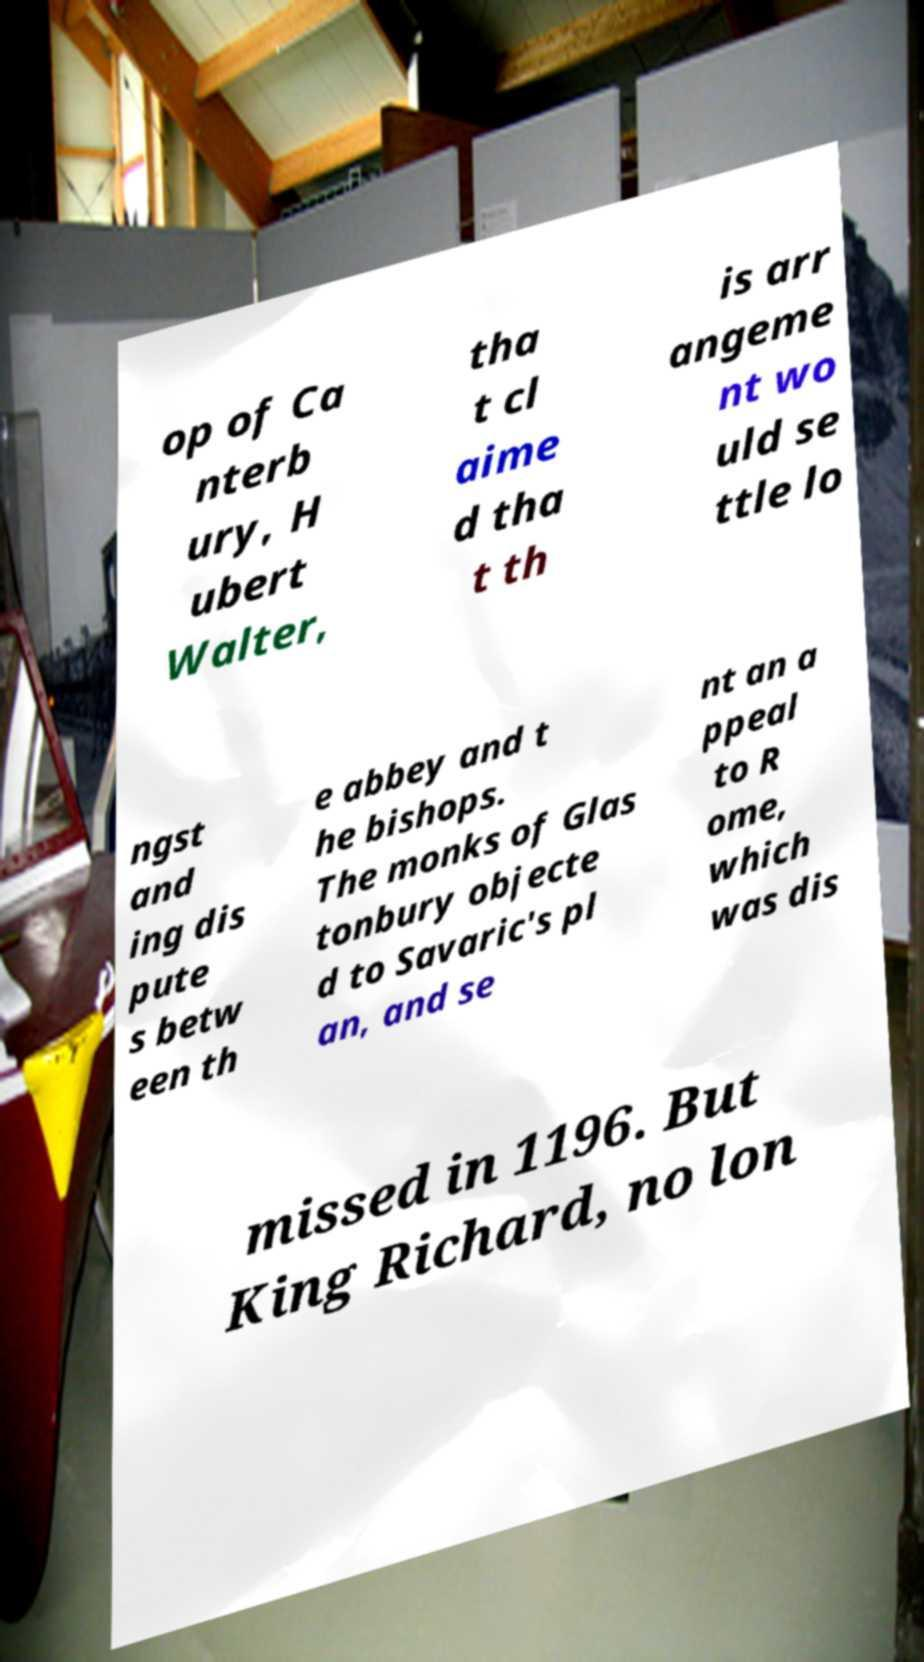Can you accurately transcribe the text from the provided image for me? op of Ca nterb ury, H ubert Walter, tha t cl aime d tha t th is arr angeme nt wo uld se ttle lo ngst and ing dis pute s betw een th e abbey and t he bishops. The monks of Glas tonbury objecte d to Savaric's pl an, and se nt an a ppeal to R ome, which was dis missed in 1196. But King Richard, no lon 